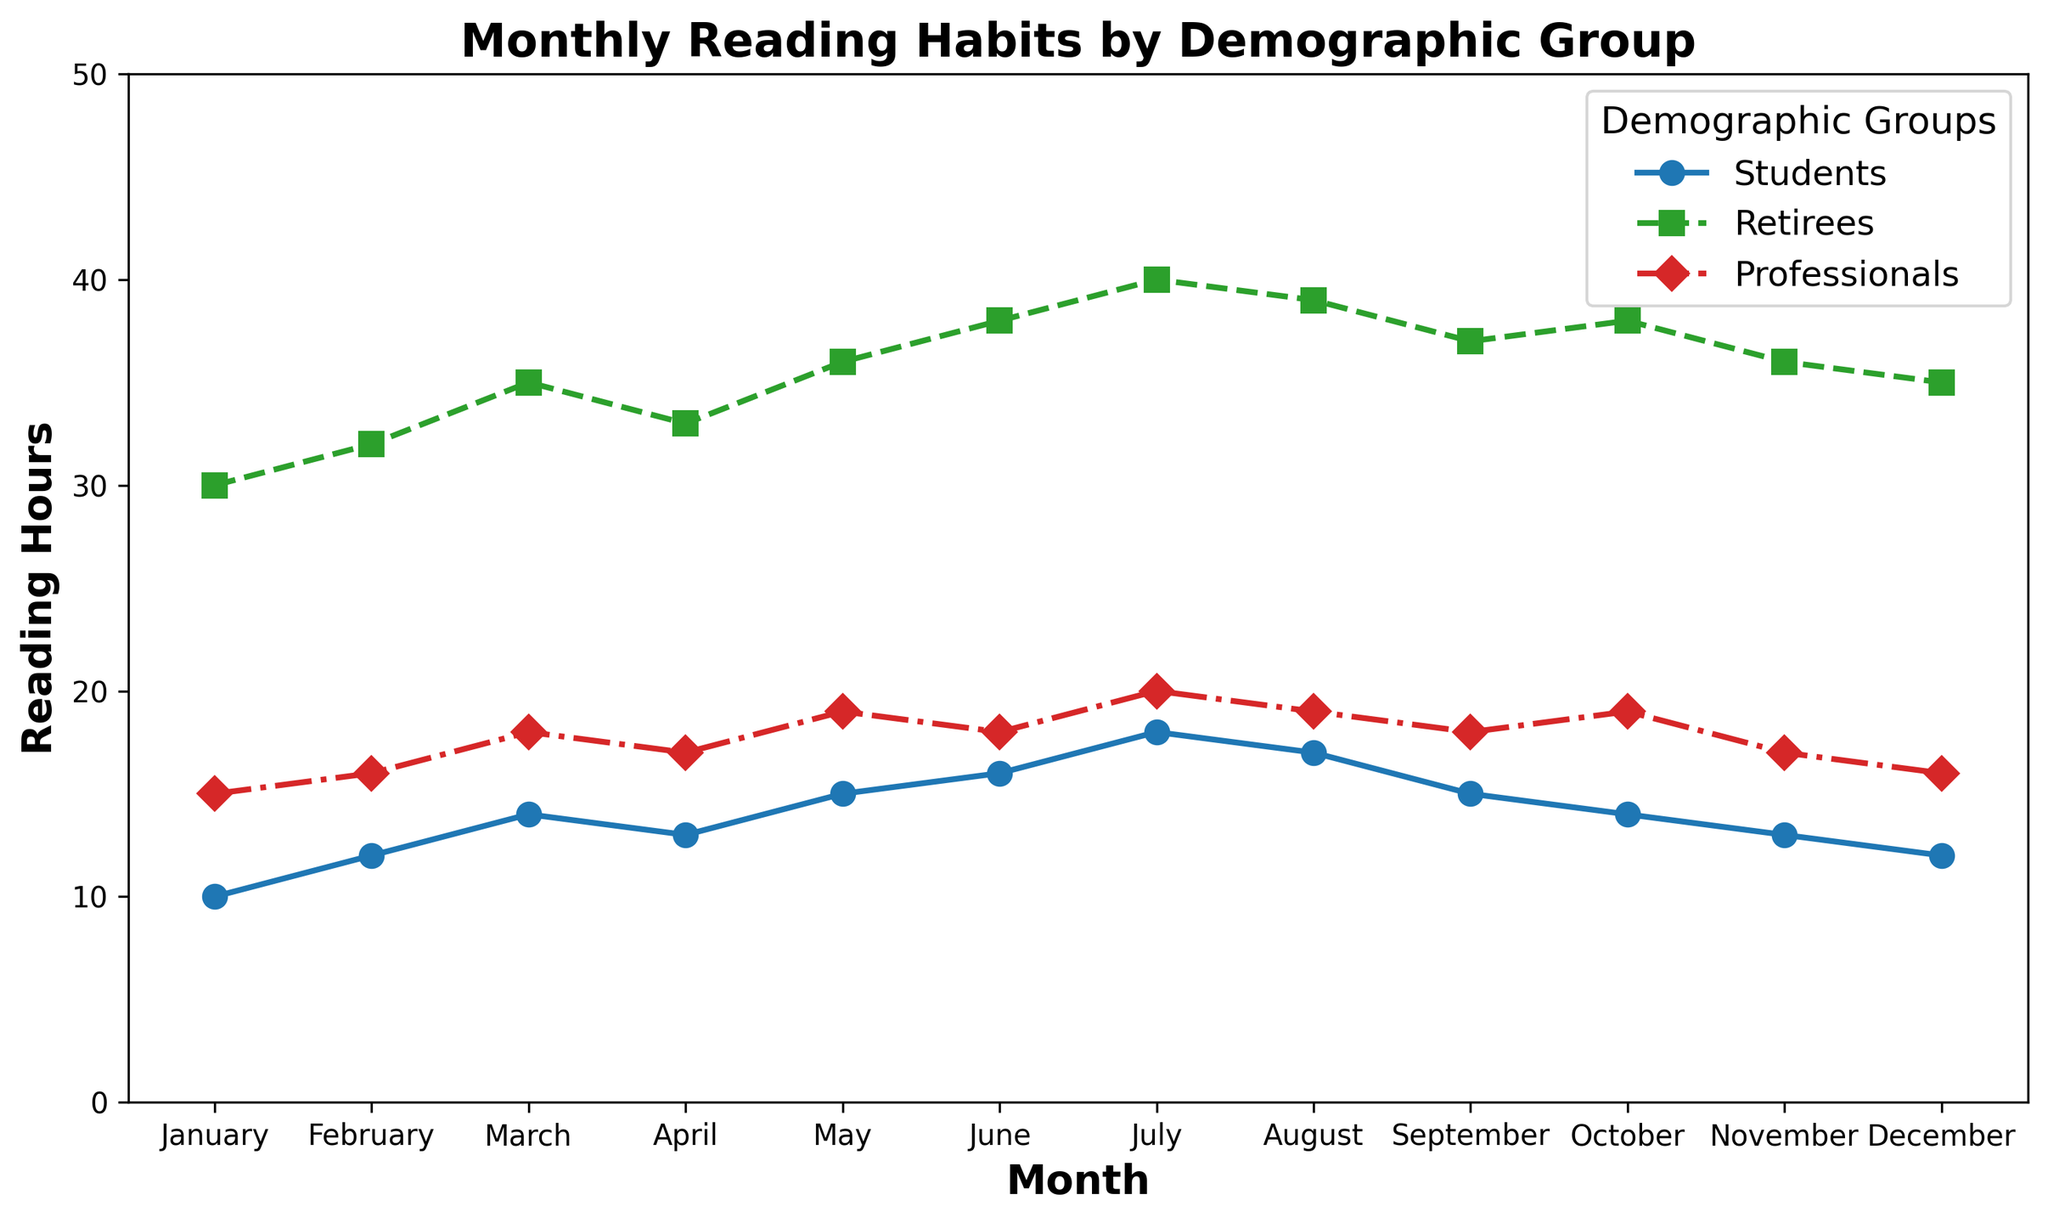What is the total reading time for students and professionals in January? Sum the reading hours for students and professionals in January from the figure. Students read for 10 hours and professionals for 15 hours. Adding these gives 10 + 15 = 25 hours.
Answer: 25 hours Which demographic group has the highest reading hours in July? From the figure, compare the reading hours in July for each group. Students: 18 hours, Retirees: 40 hours, Professionals: 20 hours. Retirees have the highest with 40 hours.
Answer: Retirees What is the difference in reading hours between retirees and professionals in November? Subtract the reading hours of professionals from retirees for November. Retirees read for 36 hours, professionals for 17 hours. The difference is 36 - 17 = 19 hours.
Answer: 19 hours In which month do professionals have the highest reading hours? From the figure, observe the reading hours for professionals across all months. The highest reading hours are in July with 20 hours.
Answer: July What is the average monthly reading time for students in the first quarter (January to March)? Add the reading hours for students from January, February, and March and then divide by 3. The hours are 10, 12, and 14, respectively. The sum is 10 + 12 + 14 = 36, so the average is 36 / 3 = 12.
Answer: 12 hours How many months do retirees read more than 35 hours? From the figure, check each month’s reading hours for retirees and count those months where the reading time is more than 35 hours: March (35), May (36), June (38), July (40), August (39), September (37), October (38). There are 7 such months.
Answer: 7 months Which group shows the most consistent reading pattern throughout the year? Compare the variation in reading hours across the months for each group. Students’ hours range from 10 to 18, retirees from 30 to 40, professionals from 15 to 20. The least variation occurs in the professionals group (15 to 20).
Answer: Professionals Do students read more in December or in April? Compare the reading hours of students in December and April from the figure. December: 12 hours, April: 13 hours. Students read more in April.
Answer: April What is the total of all reading hours for professionals throughout the year? Sum the monthly reading hours for professionals from January to December: 15 + 16 + 18 + 17 + 19 + 18 + 20 + 19 + 18 + 19 + 17 + 16. The total is 202 hours.
Answer: 202 hours 